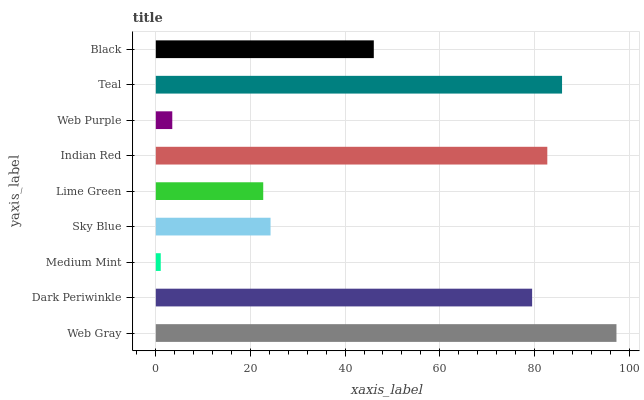Is Medium Mint the minimum?
Answer yes or no. Yes. Is Web Gray the maximum?
Answer yes or no. Yes. Is Dark Periwinkle the minimum?
Answer yes or no. No. Is Dark Periwinkle the maximum?
Answer yes or no. No. Is Web Gray greater than Dark Periwinkle?
Answer yes or no. Yes. Is Dark Periwinkle less than Web Gray?
Answer yes or no. Yes. Is Dark Periwinkle greater than Web Gray?
Answer yes or no. No. Is Web Gray less than Dark Periwinkle?
Answer yes or no. No. Is Black the high median?
Answer yes or no. Yes. Is Black the low median?
Answer yes or no. Yes. Is Medium Mint the high median?
Answer yes or no. No. Is Teal the low median?
Answer yes or no. No. 